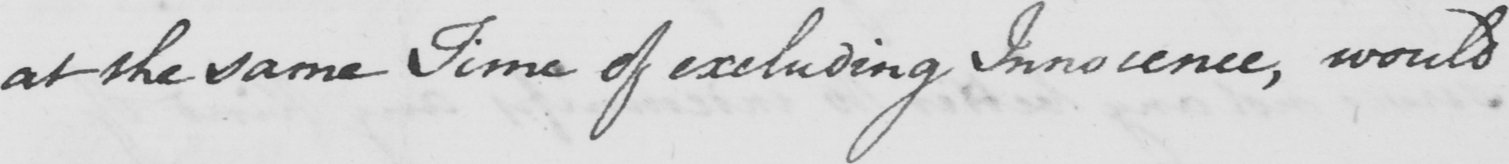Please provide the text content of this handwritten line. at the same Time of excluding Innocence , would 